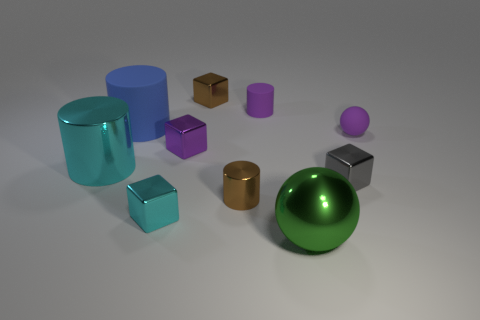Is the shape of the gray shiny thing the same as the big shiny thing to the right of the big blue cylinder?
Your answer should be very brief. No. Is there anything else that has the same size as the metallic sphere?
Offer a terse response. Yes. What size is the purple matte object that is the same shape as the green shiny object?
Make the answer very short. Small. Are there more large matte cylinders than small red metallic things?
Keep it short and to the point. Yes. Is the shape of the big cyan thing the same as the big blue matte thing?
Give a very brief answer. Yes. There is a big object on the right side of the brown metallic object that is behind the small gray thing; what is its material?
Your answer should be compact. Metal. What material is the thing that is the same color as the tiny metal cylinder?
Your answer should be very brief. Metal. Does the brown cylinder have the same size as the purple cylinder?
Offer a very short reply. Yes. There is a tiny purple block behind the large green thing; is there a small cylinder in front of it?
Your answer should be very brief. Yes. What size is the metallic block that is the same color as the tiny sphere?
Provide a short and direct response. Small. 